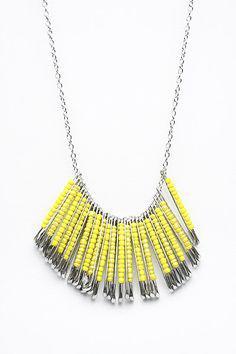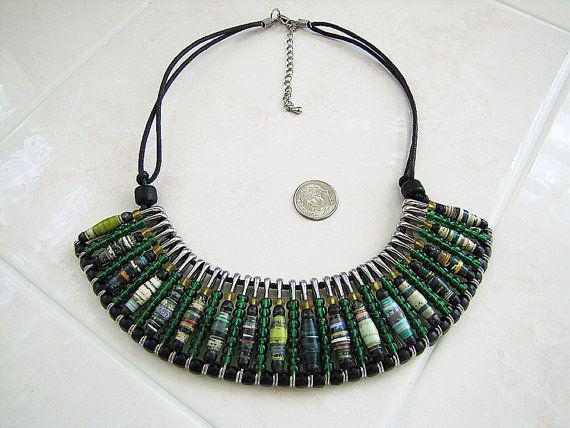The first image is the image on the left, the second image is the image on the right. Given the left and right images, does the statement "One image shows a row of six safety pins, each with a different color top, and with one of the pins open on the end" hold true? Answer yes or no. No. The first image is the image on the left, the second image is the image on the right. Examine the images to the left and right. Is the description "One of the images contains a row of safety pins and only one is open." accurate? Answer yes or no. No. 